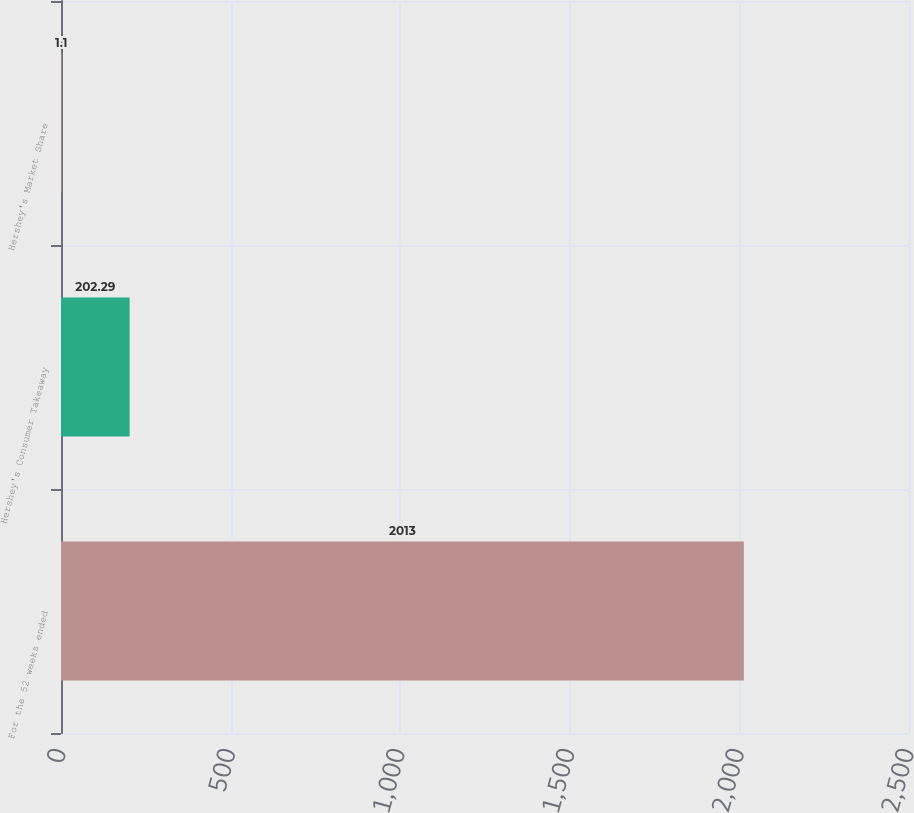Convert chart. <chart><loc_0><loc_0><loc_500><loc_500><bar_chart><fcel>For the 52 weeks ended<fcel>Hershey's Consumer Takeaway<fcel>Hershey's Market Share<nl><fcel>2013<fcel>202.29<fcel>1.1<nl></chart> 